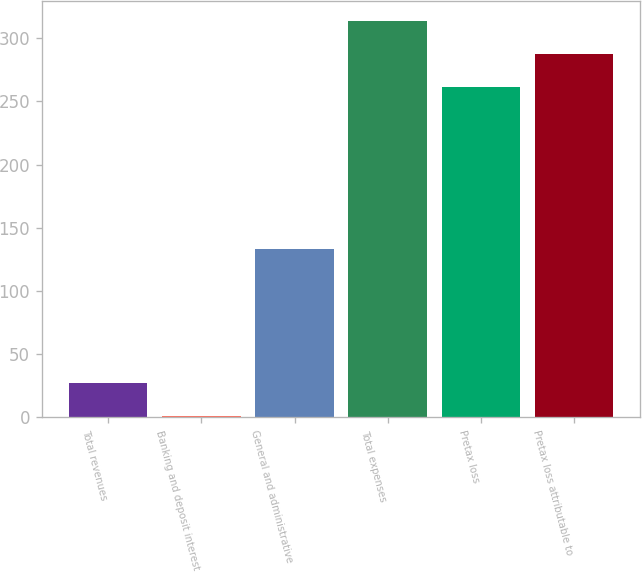Convert chart. <chart><loc_0><loc_0><loc_500><loc_500><bar_chart><fcel>Total revenues<fcel>Banking and deposit interest<fcel>General and administrative<fcel>Total expenses<fcel>Pretax loss<fcel>Pretax loss attributable to<nl><fcel>27.2<fcel>1<fcel>133<fcel>313.4<fcel>261<fcel>287.2<nl></chart> 